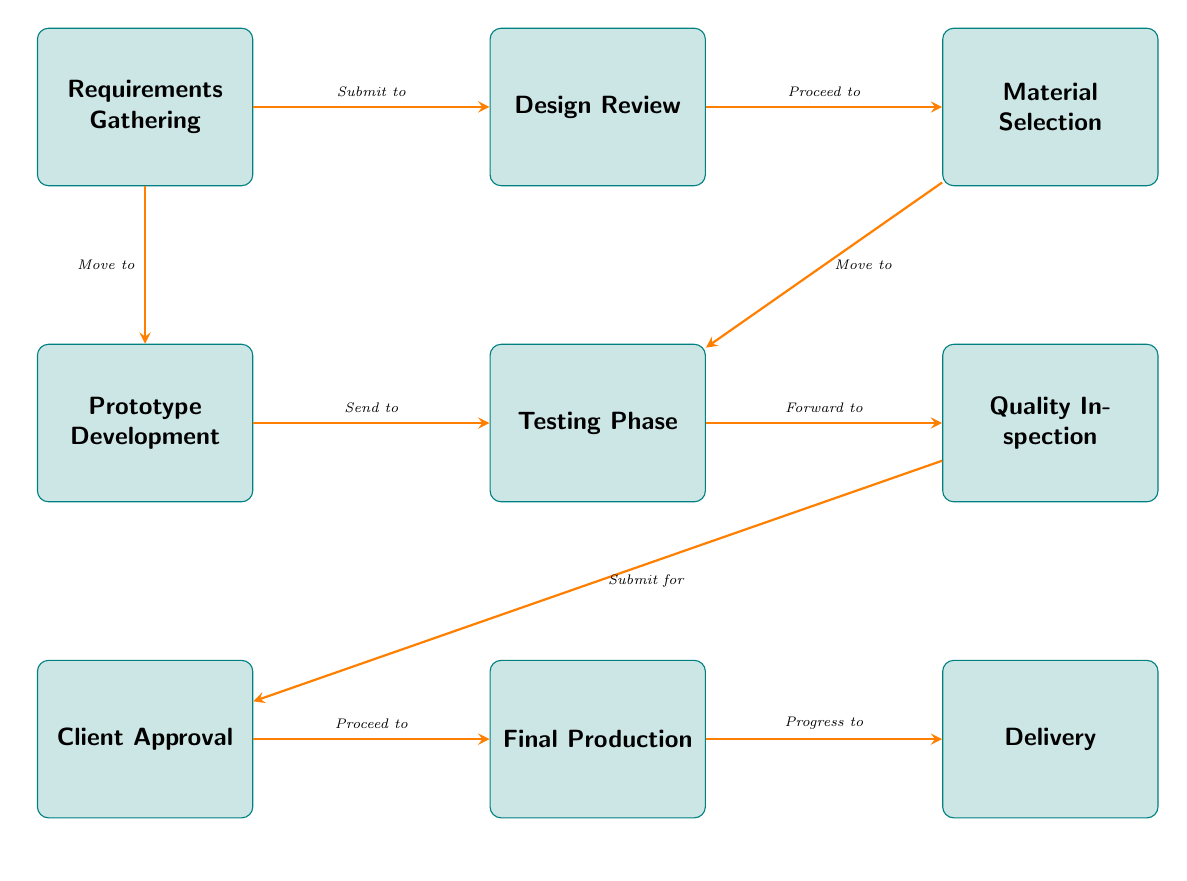What is the first step in the quality control procedure? The first step is "Requirements Gathering," which is the initial process before any other steps occur in the quality control flow.
Answer: Requirements Gathering How many processes are involved in the diagram? To find the total processes, we can count the individual nodes, which total eight: Requirements Gathering, Design Review, Material Selection, Prototype Development, Testing Phase, Quality Inspection, Client Approval, Final Production, and Delivery.
Answer: 8 What is the last step in the diagram? The final step is "Delivery," which is the last process shown after the production of the custom-designed products.
Answer: Delivery What is the purpose of the "Testing Phase"? The "Testing Phase" is designed to evaluate product performance, ensuring that the product meets specifications before moving to inspection.
Answer: Evaluate product performance Which process comes directly after "Quality Inspection"? The process that directly follows "Quality Inspection" is "Client Approval," signifying the need for the client's consent before production can commence.
Answer: Client Approval What is submitted after the "Testing Phase"? After the "Testing Phase," the process submits the results for "Quality Inspection," as indicated by the directed arrow moving from testing to inspection.
Answer: Quality Inspection Which process involves choosing materials? The process that involves selecting materials is "Material Selection," which comes after the design review step.
Answer: Material Selection What action is taken at the "Approval" step? At the "Approval" step, the action taken is to obtain the store owner's approval before proceeding to production.
Answer: Obtain store owner's approval What process develops the initial product samples? "Prototype Development" is the process responsible for creating the initial product samples before testing can begin.
Answer: Prototype Development 